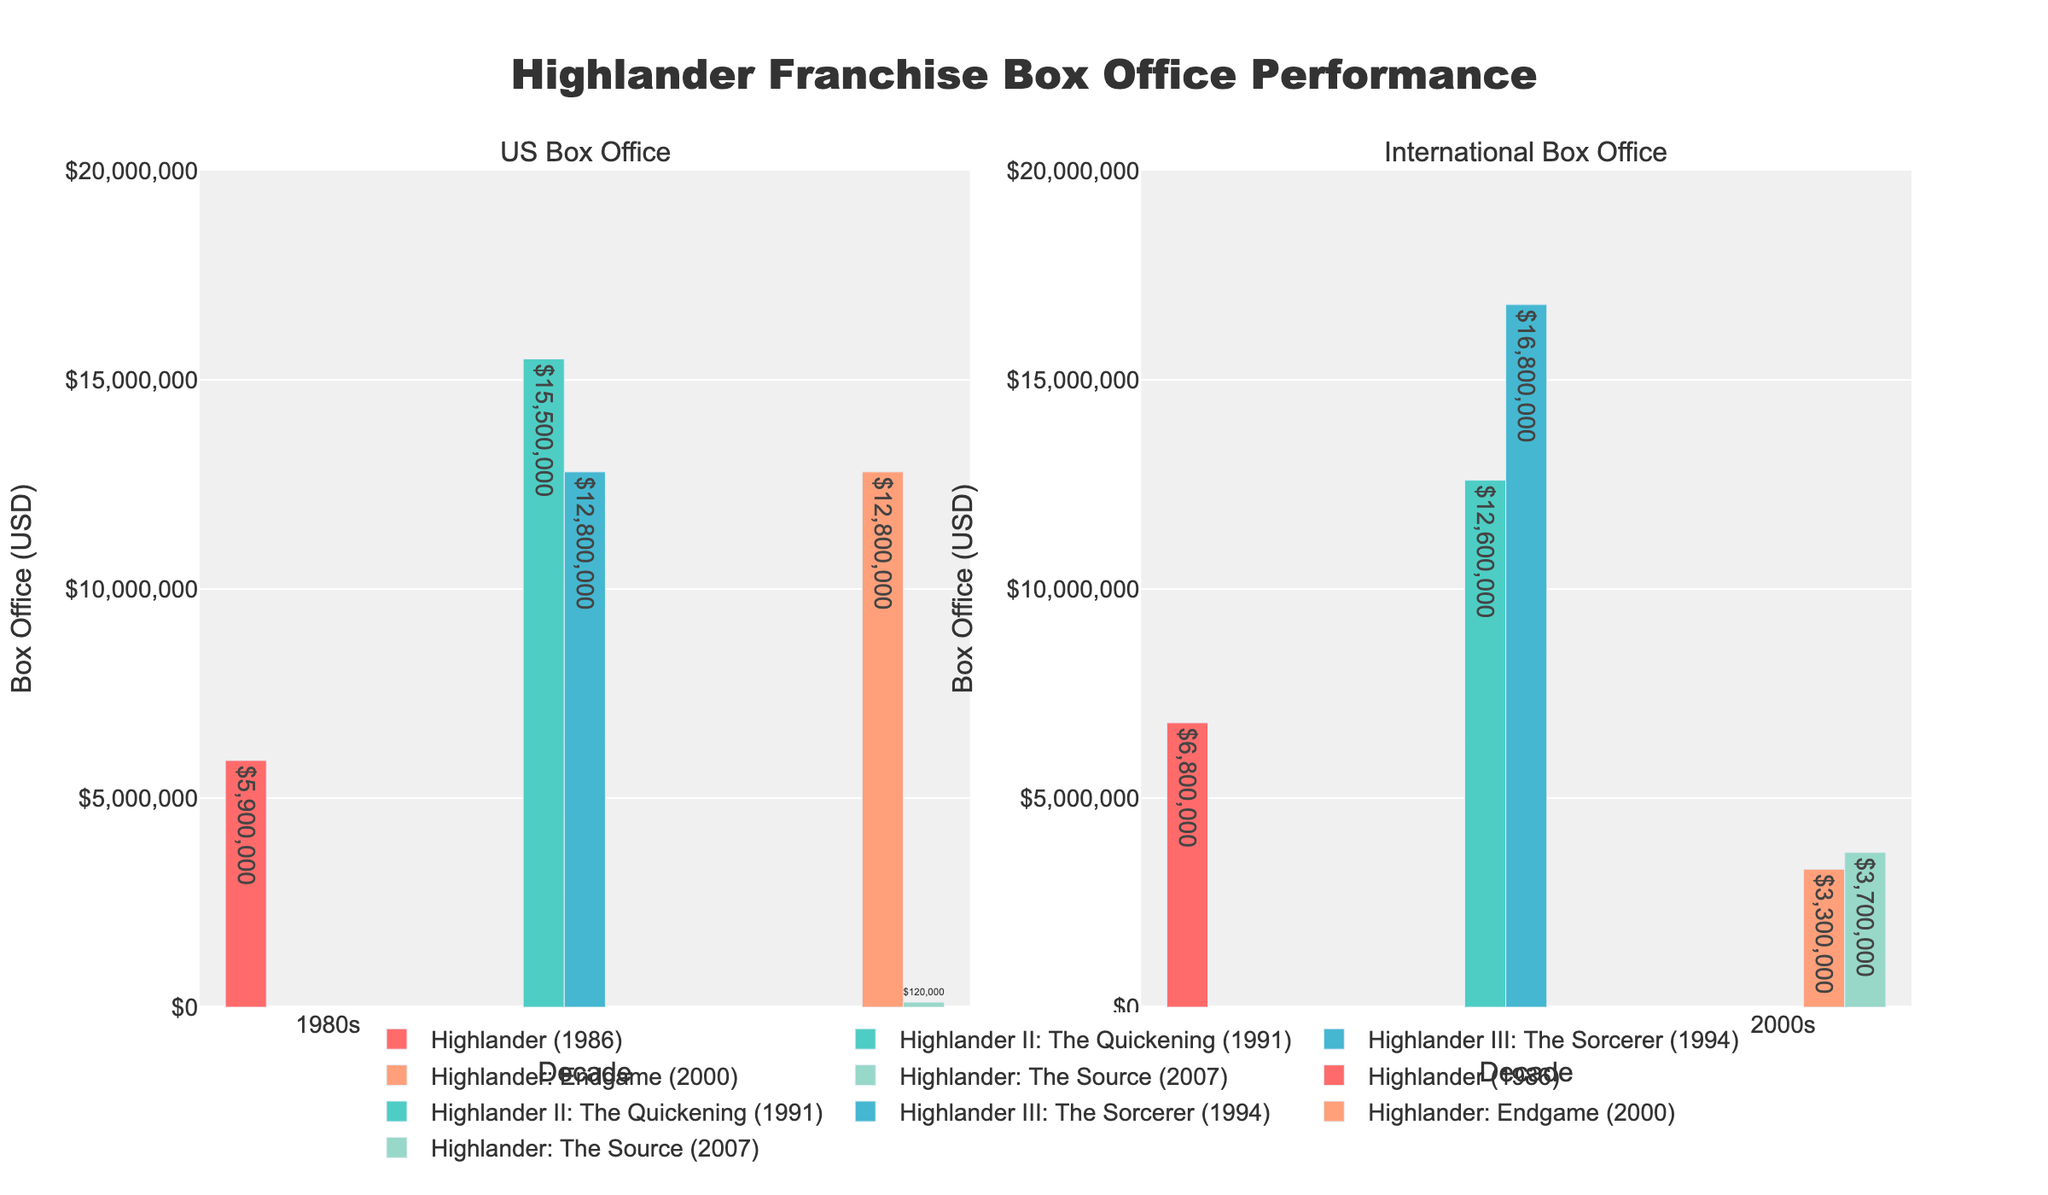What's the box office performance of "Highlander (1986)" in the US? The US box office value is directly labeled as $5,900,000 on the bar for "Highlander (1986)" in the US subplot.
Answer: $5,900,000 Which film had the highest international box office performance? By looking at the international subplot, the tallest bar corresponds to "Highlander III: The Sorcerer (1994)" with its label showing $16,800,000.
Answer: Highlander III: The Sorcerer (1994) What is the total US box office revenue for the 1990s films? Summing the US box office values of the 1990s films: Highlander II: The Quickening (1991) with $15,500,000 and Highlander III: The Sorcerer (1994) with $12,800,000, we get $15,500,000 + $12,800,000 = $28,300,000.
Answer: $28,300,000 How does the international box office revenue of "Highlander: Endgame (2000)" compare to its US box office revenue? "Highlander: Endgame (2000)" shows $3,300,000 internationally and $12,800,000 domestically in the respective subplots. Comparing these, $3,300,000 is much lower than $12,800,000.
Answer: US > International What is the average international box office revenue for the films in the 2000s? The films of the 2000s are Highlander: Endgame (2000) with $3,300,000 and Highlander: The Source (2007) with $3,700,000. Adding these: $3,300,000 + $3,700,000 = $7,000,000. The average is $7,000,000 / 2 = $3,500,000.
Answer: $3,500,000 What decade saw the highest combined box office revenue across both subplots? Summing both US and International revenues by decade: 1980s has $5,900,000 + $6,800,000 = $12,700,000, 1990s has $28,300,000 + $29,400,000 = $57,700,000, 2000s has $25,600,000 + $7,000,000 = $32,600,000. The 1990s have the highest combined revenue of $57,700,000.
Answer: 1990s Which film had the lowest box office revenue internationally and what was the value? In the international subplot, the shortest bar is for "Highlander: Endgame (2000)" with a value of $3,300,000.
Answer: Highlander: Endgame (2000), $3,300,000 Did any film perform better internationally than in the US? If so, which one? Comparing the international and US revenue for each film, "Highlander III: The Sorcerer (1994)" had $16,800,000 internationally, which is higher than its $12,800,000 US revenue.
Answer: Highlander III: The Sorcerer (1994) What was the combined box office revenue for all "Highlander" films in the 2000s? Adding both US and International revenues for the 2000s films: Highlander: Endgame (2000) with $12,800,000 + $3,300,000 and Highlander: The Source (2007) with $120,000 + $3,700,000, we get $12,800,000 + $3,300,000 + $120,000 + $3,700,000 = $19,920,000.
Answer: $19,920,000 